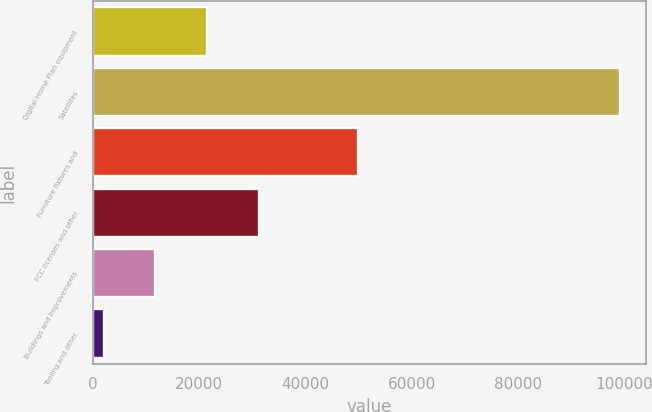<chart> <loc_0><loc_0><loc_500><loc_500><bar_chart><fcel>Digital Home Plan equipment<fcel>Satellites<fcel>Furniture fixtures and<fcel>FCC licenses and other<fcel>Buildings and improvements<fcel>Tooling and other<nl><fcel>21522.4<fcel>99144<fcel>49988<fcel>31225.1<fcel>11819.7<fcel>2117<nl></chart> 